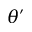<formula> <loc_0><loc_0><loc_500><loc_500>\theta ^ { \prime }</formula> 